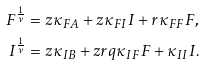<formula> <loc_0><loc_0><loc_500><loc_500>F ^ { \frac { 1 } { \nu } } & = z \kappa _ { F A } + z \kappa _ { F I } I + r \kappa _ { F F } F , \\ I ^ { \frac { 1 } { \nu } } & = z \kappa _ { I B } + z r q \kappa _ { I F } F + \kappa _ { I I } I .</formula> 